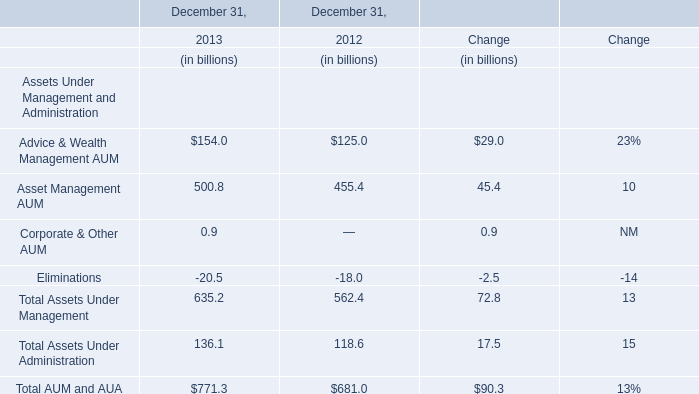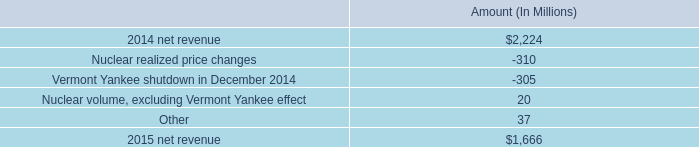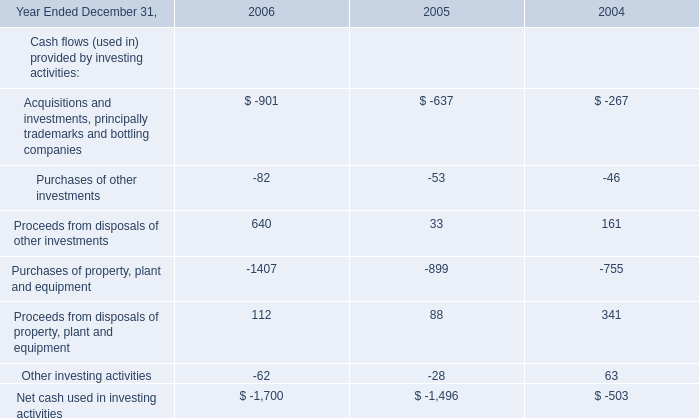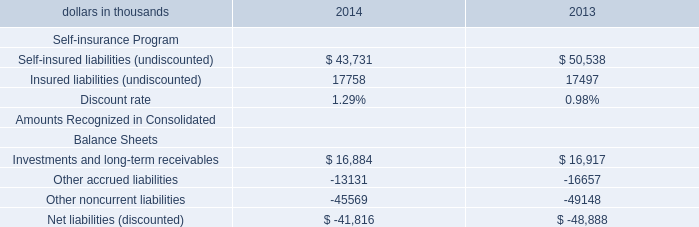What's the total amount of Advice & Wealth Management AUM, Asset Management AUM, Corporate & Other AUM and Eliminationsin 2013? (in billion) 
Computations: (((154 + 500.8) + 0.9) - 20.5)
Answer: 635.2. 